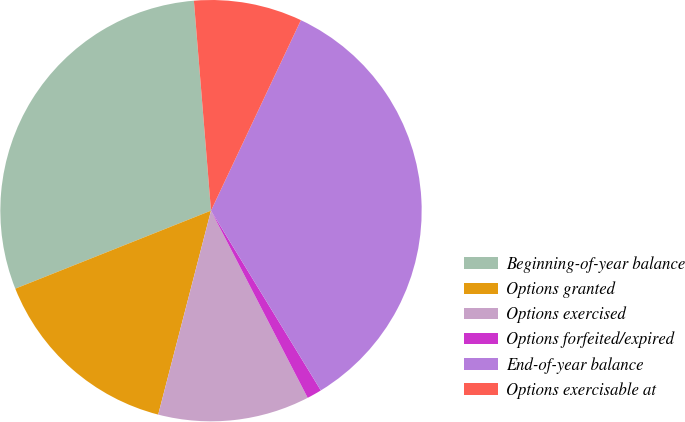<chart> <loc_0><loc_0><loc_500><loc_500><pie_chart><fcel>Beginning-of-year balance<fcel>Options granted<fcel>Options exercised<fcel>Options forfeited/expired<fcel>End-of-year balance<fcel>Options exercisable at<nl><fcel>29.74%<fcel>14.93%<fcel>11.62%<fcel>1.14%<fcel>34.25%<fcel>8.31%<nl></chart> 